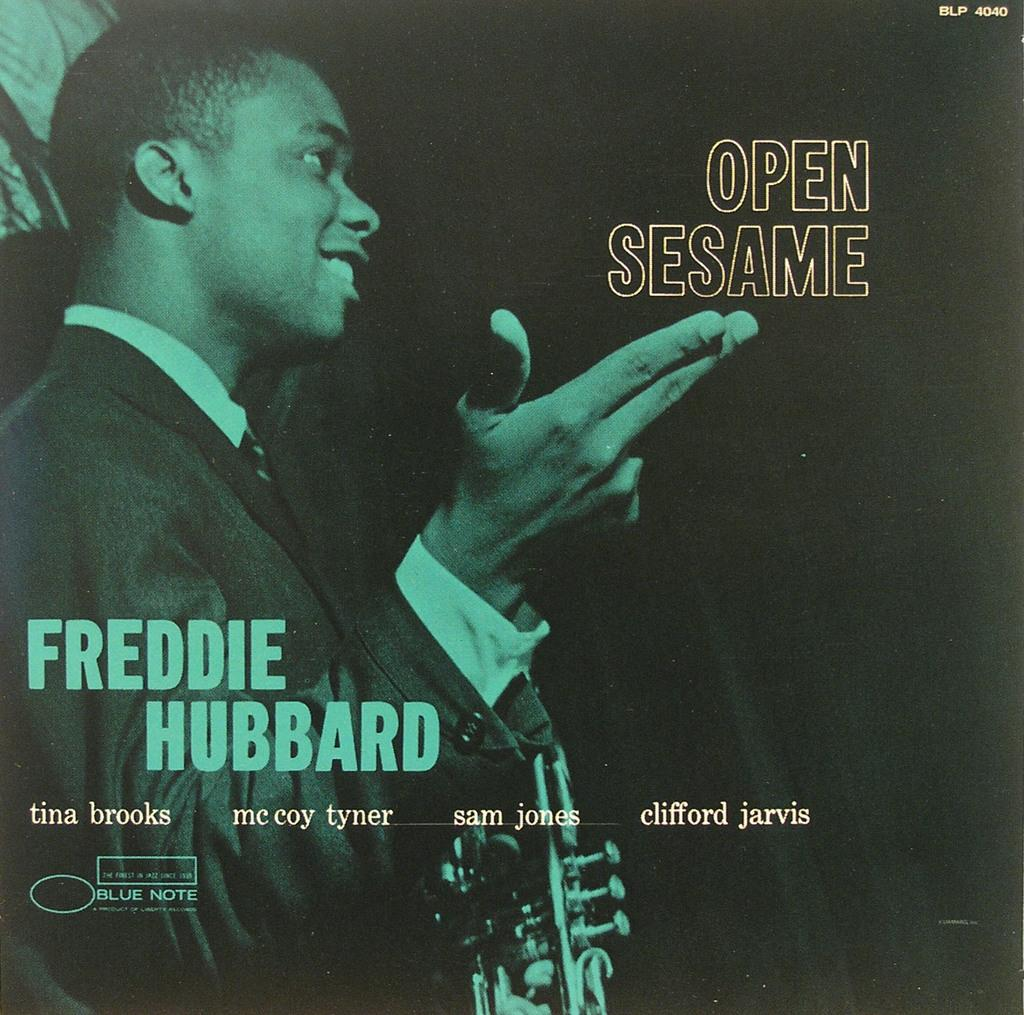<image>
Offer a succinct explanation of the picture presented. The album cover Open Sesame by Freddie Hubbard. 